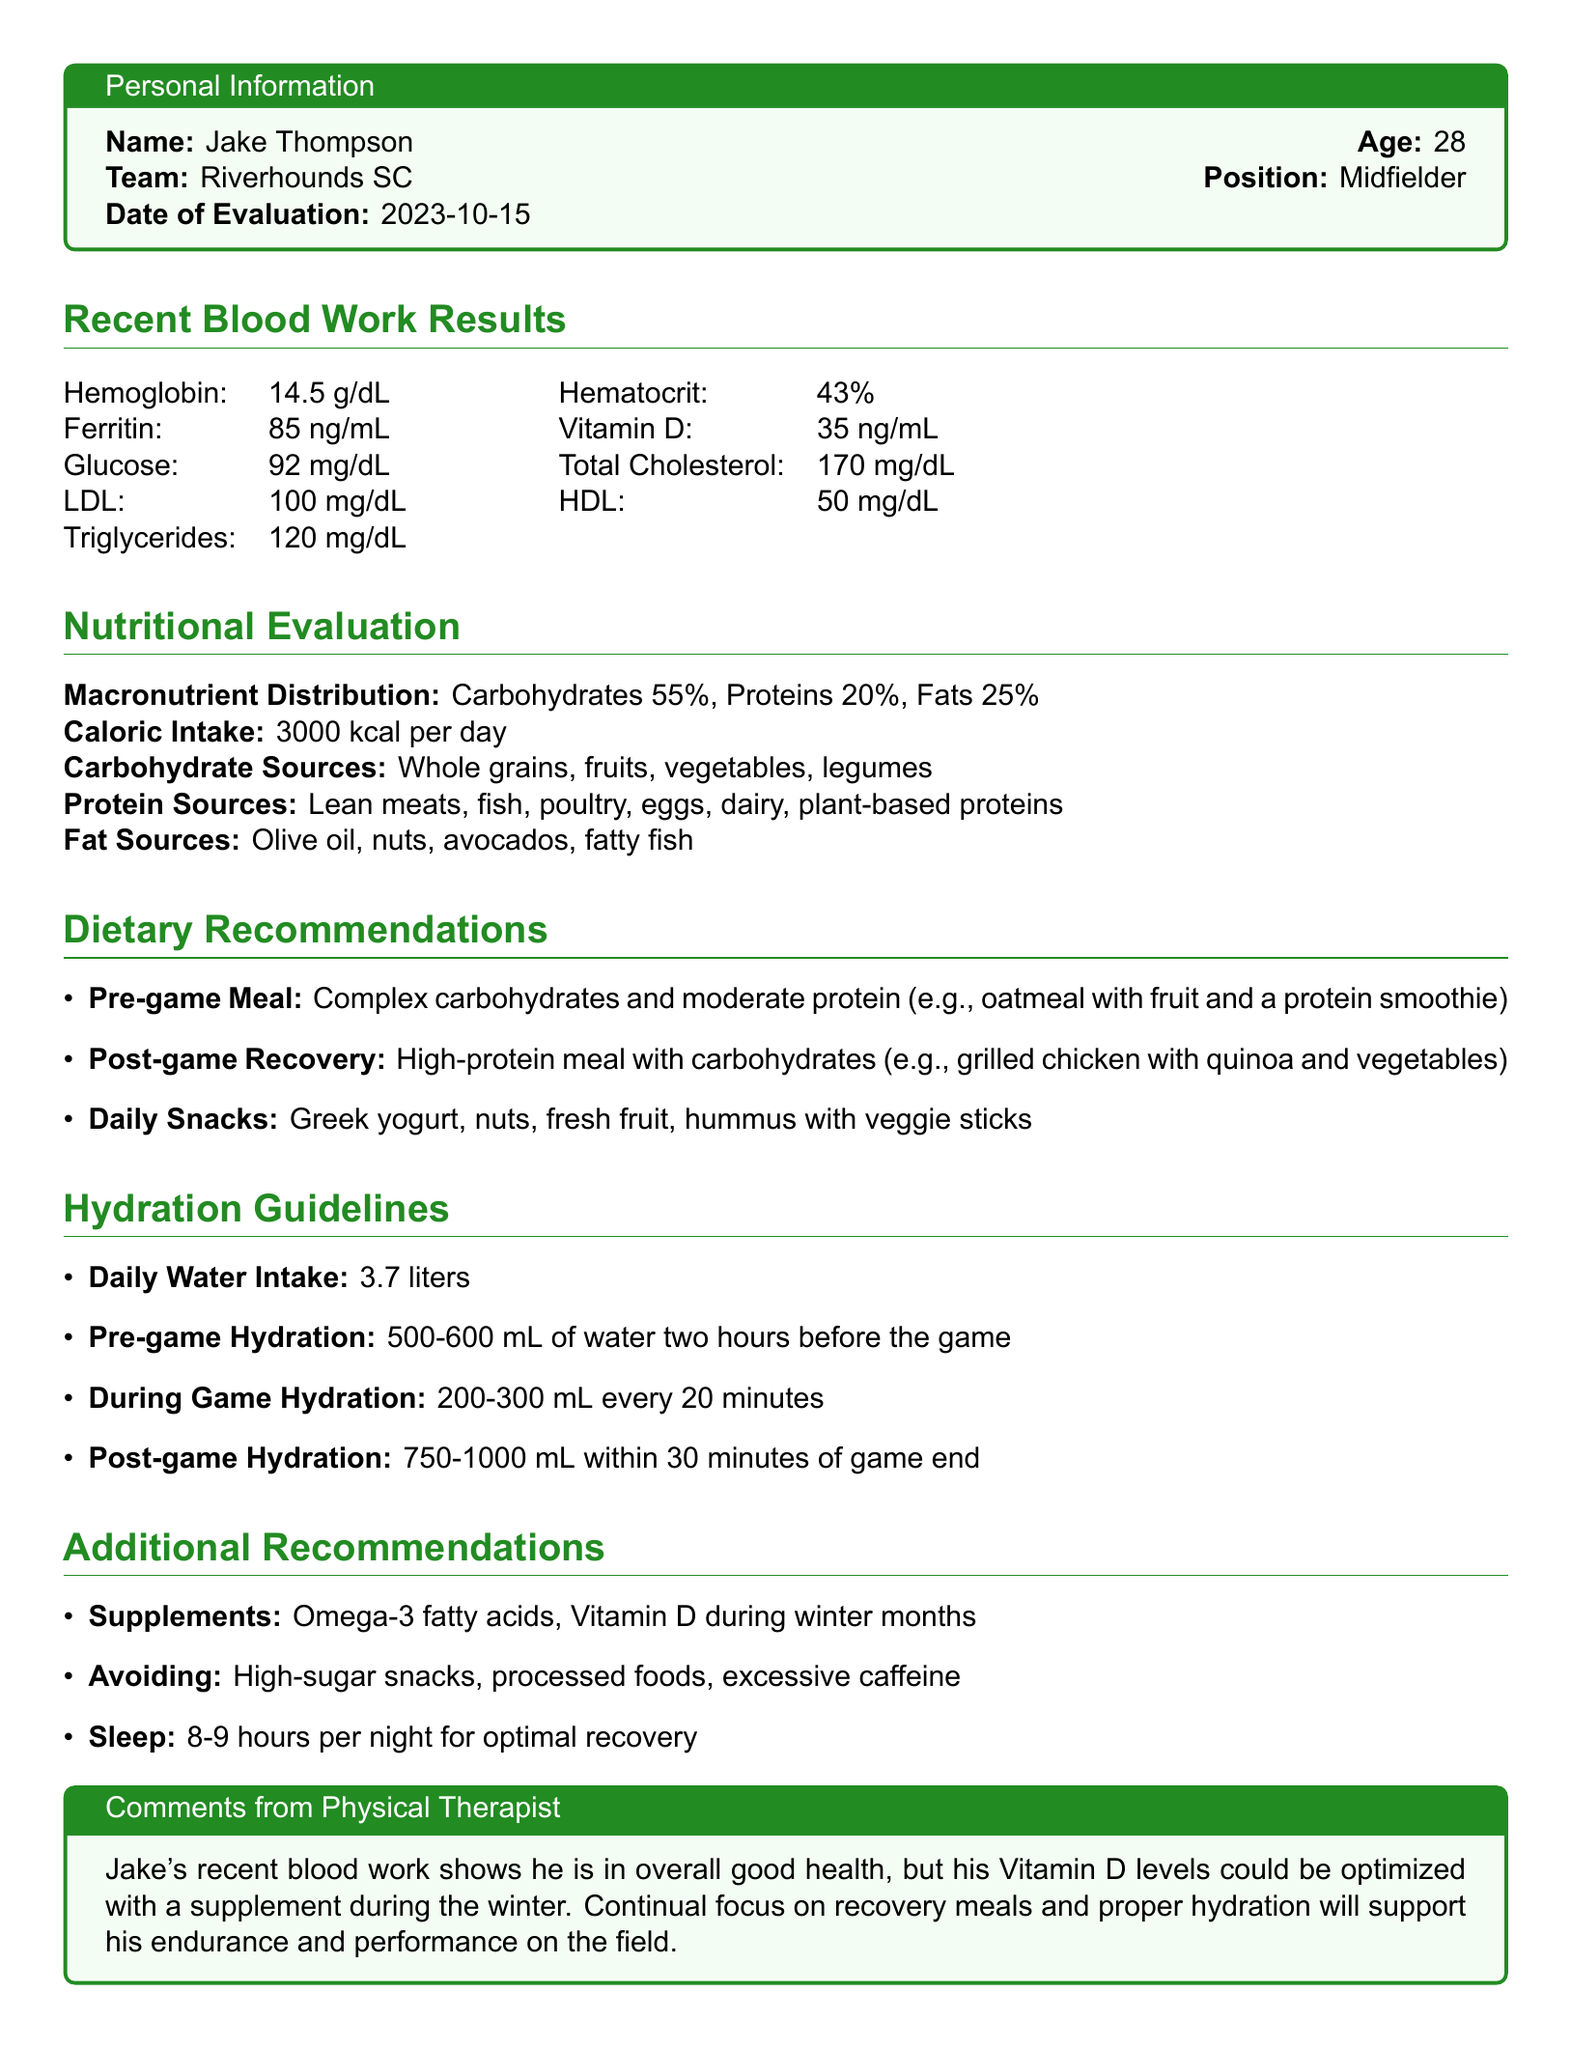What is Jake's age? Jake's age is explicitly stated in the personal information section of the document.
Answer: 28 What is the daily caloric intake recommended for Jake? The document specifies that Jake's caloric intake is detailed under nutritional evaluation.
Answer: 3000 kcal per day What percentage of Jake's macronutrient distribution is allocated to fats? The macronutrient distribution section outlines the percentages for fats.
Answer: 25% How much water should Jake drink daily according to hydration guidelines? The hydration guidelines provide recommendations for Jake's daily water intake.
Answer: 3.7 liters What supplement is recommended during winter months? The document mentions the specific supplement that should be taken during winter.
Answer: Vitamin D What is the pre-game hydration amount suggested for Jake? The hydration guidelines indicate the specific amount of water recommended before a game.
Answer: 500-600 mL What are the primary carbohydrate sources listed for Jake's diet? The nutritional evaluation section lists the sources of carbohydrates for Jake.
Answer: Whole grains, fruits, vegetables, legumes What is the recommended amount of sleep for optimal recovery? The additional recommendations section includes the ideal amount of sleep for recovery.
Answer: 8-9 hours What does Jake need to avoid according to the dietary recommendations? The document specifies dietary restrictions in the additional recommendations section.
Answer: High-sugar snacks, processed foods, excessive caffeine 